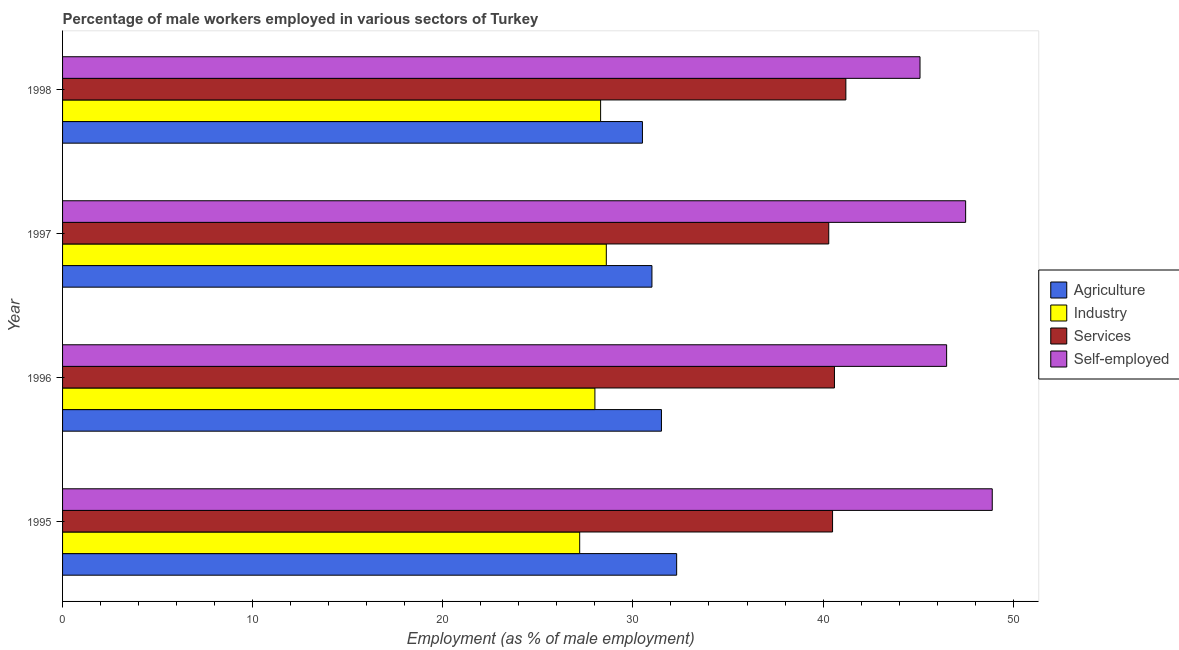How many different coloured bars are there?
Make the answer very short. 4. Are the number of bars per tick equal to the number of legend labels?
Offer a very short reply. Yes. How many bars are there on the 1st tick from the top?
Offer a very short reply. 4. How many bars are there on the 4th tick from the bottom?
Offer a terse response. 4. In how many cases, is the number of bars for a given year not equal to the number of legend labels?
Provide a short and direct response. 0. What is the percentage of male workers in agriculture in 1996?
Give a very brief answer. 31.5. Across all years, what is the maximum percentage of male workers in services?
Make the answer very short. 41.2. Across all years, what is the minimum percentage of male workers in agriculture?
Keep it short and to the point. 30.5. In which year was the percentage of male workers in industry minimum?
Give a very brief answer. 1995. What is the total percentage of male workers in agriculture in the graph?
Your response must be concise. 125.3. What is the difference between the percentage of self employed male workers in 1995 and that in 1996?
Ensure brevity in your answer.  2.4. What is the difference between the percentage of self employed male workers in 1997 and the percentage of male workers in agriculture in 1996?
Keep it short and to the point. 16. What is the average percentage of male workers in agriculture per year?
Offer a terse response. 31.32. In the year 1995, what is the difference between the percentage of male workers in services and percentage of male workers in agriculture?
Ensure brevity in your answer.  8.2. In how many years, is the percentage of male workers in services greater than 20 %?
Your response must be concise. 4. What is the ratio of the percentage of male workers in industry in 1995 to that in 1996?
Keep it short and to the point. 0.97. Is the difference between the percentage of male workers in services in 1996 and 1998 greater than the difference between the percentage of male workers in industry in 1996 and 1998?
Ensure brevity in your answer.  No. What is the difference between the highest and the lowest percentage of male workers in industry?
Your answer should be compact. 1.4. In how many years, is the percentage of self employed male workers greater than the average percentage of self employed male workers taken over all years?
Make the answer very short. 2. Is the sum of the percentage of male workers in agriculture in 1997 and 1998 greater than the maximum percentage of male workers in industry across all years?
Keep it short and to the point. Yes. Is it the case that in every year, the sum of the percentage of male workers in services and percentage of self employed male workers is greater than the sum of percentage of male workers in agriculture and percentage of male workers in industry?
Ensure brevity in your answer.  Yes. What does the 1st bar from the top in 1996 represents?
Provide a succinct answer. Self-employed. What does the 3rd bar from the bottom in 1998 represents?
Your answer should be compact. Services. How many bars are there?
Provide a succinct answer. 16. Are all the bars in the graph horizontal?
Ensure brevity in your answer.  Yes. What is the difference between two consecutive major ticks on the X-axis?
Offer a terse response. 10. Does the graph contain any zero values?
Make the answer very short. No. Does the graph contain grids?
Provide a succinct answer. No. Where does the legend appear in the graph?
Ensure brevity in your answer.  Center right. How are the legend labels stacked?
Provide a succinct answer. Vertical. What is the title of the graph?
Provide a succinct answer. Percentage of male workers employed in various sectors of Turkey. Does "Primary education" appear as one of the legend labels in the graph?
Ensure brevity in your answer.  No. What is the label or title of the X-axis?
Your answer should be compact. Employment (as % of male employment). What is the label or title of the Y-axis?
Your response must be concise. Year. What is the Employment (as % of male employment) of Agriculture in 1995?
Provide a short and direct response. 32.3. What is the Employment (as % of male employment) of Industry in 1995?
Give a very brief answer. 27.2. What is the Employment (as % of male employment) in Services in 1995?
Your response must be concise. 40.5. What is the Employment (as % of male employment) in Self-employed in 1995?
Your answer should be compact. 48.9. What is the Employment (as % of male employment) of Agriculture in 1996?
Your answer should be compact. 31.5. What is the Employment (as % of male employment) of Services in 1996?
Offer a terse response. 40.6. What is the Employment (as % of male employment) of Self-employed in 1996?
Make the answer very short. 46.5. What is the Employment (as % of male employment) in Agriculture in 1997?
Provide a succinct answer. 31. What is the Employment (as % of male employment) of Industry in 1997?
Your response must be concise. 28.6. What is the Employment (as % of male employment) in Services in 1997?
Make the answer very short. 40.3. What is the Employment (as % of male employment) in Self-employed in 1997?
Ensure brevity in your answer.  47.5. What is the Employment (as % of male employment) in Agriculture in 1998?
Provide a succinct answer. 30.5. What is the Employment (as % of male employment) in Industry in 1998?
Give a very brief answer. 28.3. What is the Employment (as % of male employment) of Services in 1998?
Provide a short and direct response. 41.2. What is the Employment (as % of male employment) in Self-employed in 1998?
Provide a short and direct response. 45.1. Across all years, what is the maximum Employment (as % of male employment) of Agriculture?
Ensure brevity in your answer.  32.3. Across all years, what is the maximum Employment (as % of male employment) of Industry?
Provide a short and direct response. 28.6. Across all years, what is the maximum Employment (as % of male employment) of Services?
Ensure brevity in your answer.  41.2. Across all years, what is the maximum Employment (as % of male employment) in Self-employed?
Give a very brief answer. 48.9. Across all years, what is the minimum Employment (as % of male employment) in Agriculture?
Keep it short and to the point. 30.5. Across all years, what is the minimum Employment (as % of male employment) of Industry?
Keep it short and to the point. 27.2. Across all years, what is the minimum Employment (as % of male employment) in Services?
Provide a short and direct response. 40.3. Across all years, what is the minimum Employment (as % of male employment) of Self-employed?
Ensure brevity in your answer.  45.1. What is the total Employment (as % of male employment) of Agriculture in the graph?
Provide a short and direct response. 125.3. What is the total Employment (as % of male employment) in Industry in the graph?
Keep it short and to the point. 112.1. What is the total Employment (as % of male employment) of Services in the graph?
Make the answer very short. 162.6. What is the total Employment (as % of male employment) in Self-employed in the graph?
Make the answer very short. 188. What is the difference between the Employment (as % of male employment) in Agriculture in 1995 and that in 1996?
Your response must be concise. 0.8. What is the difference between the Employment (as % of male employment) in Industry in 1995 and that in 1996?
Ensure brevity in your answer.  -0.8. What is the difference between the Employment (as % of male employment) of Services in 1995 and that in 1996?
Your answer should be very brief. -0.1. What is the difference between the Employment (as % of male employment) in Self-employed in 1995 and that in 1996?
Your answer should be compact. 2.4. What is the difference between the Employment (as % of male employment) in Agriculture in 1995 and that in 1997?
Your answer should be very brief. 1.3. What is the difference between the Employment (as % of male employment) in Industry in 1995 and that in 1997?
Make the answer very short. -1.4. What is the difference between the Employment (as % of male employment) of Self-employed in 1995 and that in 1997?
Your response must be concise. 1.4. What is the difference between the Employment (as % of male employment) of Industry in 1995 and that in 1998?
Make the answer very short. -1.1. What is the difference between the Employment (as % of male employment) in Services in 1995 and that in 1998?
Ensure brevity in your answer.  -0.7. What is the difference between the Employment (as % of male employment) in Self-employed in 1995 and that in 1998?
Provide a succinct answer. 3.8. What is the difference between the Employment (as % of male employment) of Agriculture in 1996 and that in 1997?
Give a very brief answer. 0.5. What is the difference between the Employment (as % of male employment) of Industry in 1996 and that in 1997?
Offer a very short reply. -0.6. What is the difference between the Employment (as % of male employment) in Services in 1996 and that in 1997?
Your response must be concise. 0.3. What is the difference between the Employment (as % of male employment) of Self-employed in 1996 and that in 1997?
Offer a terse response. -1. What is the difference between the Employment (as % of male employment) of Industry in 1996 and that in 1998?
Give a very brief answer. -0.3. What is the difference between the Employment (as % of male employment) of Self-employed in 1996 and that in 1998?
Offer a terse response. 1.4. What is the difference between the Employment (as % of male employment) in Industry in 1997 and that in 1998?
Make the answer very short. 0.3. What is the difference between the Employment (as % of male employment) in Self-employed in 1997 and that in 1998?
Offer a terse response. 2.4. What is the difference between the Employment (as % of male employment) of Agriculture in 1995 and the Employment (as % of male employment) of Industry in 1996?
Offer a very short reply. 4.3. What is the difference between the Employment (as % of male employment) in Agriculture in 1995 and the Employment (as % of male employment) in Self-employed in 1996?
Keep it short and to the point. -14.2. What is the difference between the Employment (as % of male employment) in Industry in 1995 and the Employment (as % of male employment) in Services in 1996?
Give a very brief answer. -13.4. What is the difference between the Employment (as % of male employment) of Industry in 1995 and the Employment (as % of male employment) of Self-employed in 1996?
Provide a short and direct response. -19.3. What is the difference between the Employment (as % of male employment) in Services in 1995 and the Employment (as % of male employment) in Self-employed in 1996?
Ensure brevity in your answer.  -6. What is the difference between the Employment (as % of male employment) in Agriculture in 1995 and the Employment (as % of male employment) in Industry in 1997?
Make the answer very short. 3.7. What is the difference between the Employment (as % of male employment) in Agriculture in 1995 and the Employment (as % of male employment) in Self-employed in 1997?
Keep it short and to the point. -15.2. What is the difference between the Employment (as % of male employment) of Industry in 1995 and the Employment (as % of male employment) of Self-employed in 1997?
Offer a very short reply. -20.3. What is the difference between the Employment (as % of male employment) of Agriculture in 1995 and the Employment (as % of male employment) of Industry in 1998?
Your response must be concise. 4. What is the difference between the Employment (as % of male employment) of Agriculture in 1995 and the Employment (as % of male employment) of Services in 1998?
Make the answer very short. -8.9. What is the difference between the Employment (as % of male employment) of Agriculture in 1995 and the Employment (as % of male employment) of Self-employed in 1998?
Provide a succinct answer. -12.8. What is the difference between the Employment (as % of male employment) of Industry in 1995 and the Employment (as % of male employment) of Services in 1998?
Provide a short and direct response. -14. What is the difference between the Employment (as % of male employment) of Industry in 1995 and the Employment (as % of male employment) of Self-employed in 1998?
Provide a succinct answer. -17.9. What is the difference between the Employment (as % of male employment) of Services in 1995 and the Employment (as % of male employment) of Self-employed in 1998?
Your response must be concise. -4.6. What is the difference between the Employment (as % of male employment) in Agriculture in 1996 and the Employment (as % of male employment) in Industry in 1997?
Ensure brevity in your answer.  2.9. What is the difference between the Employment (as % of male employment) in Agriculture in 1996 and the Employment (as % of male employment) in Services in 1997?
Provide a short and direct response. -8.8. What is the difference between the Employment (as % of male employment) in Agriculture in 1996 and the Employment (as % of male employment) in Self-employed in 1997?
Your response must be concise. -16. What is the difference between the Employment (as % of male employment) of Industry in 1996 and the Employment (as % of male employment) of Services in 1997?
Provide a succinct answer. -12.3. What is the difference between the Employment (as % of male employment) in Industry in 1996 and the Employment (as % of male employment) in Self-employed in 1997?
Your answer should be compact. -19.5. What is the difference between the Employment (as % of male employment) of Services in 1996 and the Employment (as % of male employment) of Self-employed in 1997?
Give a very brief answer. -6.9. What is the difference between the Employment (as % of male employment) of Agriculture in 1996 and the Employment (as % of male employment) of Industry in 1998?
Offer a terse response. 3.2. What is the difference between the Employment (as % of male employment) in Industry in 1996 and the Employment (as % of male employment) in Self-employed in 1998?
Your answer should be compact. -17.1. What is the difference between the Employment (as % of male employment) of Agriculture in 1997 and the Employment (as % of male employment) of Industry in 1998?
Your response must be concise. 2.7. What is the difference between the Employment (as % of male employment) in Agriculture in 1997 and the Employment (as % of male employment) in Services in 1998?
Provide a succinct answer. -10.2. What is the difference between the Employment (as % of male employment) of Agriculture in 1997 and the Employment (as % of male employment) of Self-employed in 1998?
Provide a succinct answer. -14.1. What is the difference between the Employment (as % of male employment) of Industry in 1997 and the Employment (as % of male employment) of Services in 1998?
Give a very brief answer. -12.6. What is the difference between the Employment (as % of male employment) of Industry in 1997 and the Employment (as % of male employment) of Self-employed in 1998?
Keep it short and to the point. -16.5. What is the difference between the Employment (as % of male employment) in Services in 1997 and the Employment (as % of male employment) in Self-employed in 1998?
Give a very brief answer. -4.8. What is the average Employment (as % of male employment) of Agriculture per year?
Provide a succinct answer. 31.32. What is the average Employment (as % of male employment) of Industry per year?
Your answer should be very brief. 28.02. What is the average Employment (as % of male employment) of Services per year?
Make the answer very short. 40.65. In the year 1995, what is the difference between the Employment (as % of male employment) in Agriculture and Employment (as % of male employment) in Services?
Your answer should be compact. -8.2. In the year 1995, what is the difference between the Employment (as % of male employment) in Agriculture and Employment (as % of male employment) in Self-employed?
Offer a terse response. -16.6. In the year 1995, what is the difference between the Employment (as % of male employment) in Industry and Employment (as % of male employment) in Services?
Provide a succinct answer. -13.3. In the year 1995, what is the difference between the Employment (as % of male employment) in Industry and Employment (as % of male employment) in Self-employed?
Provide a short and direct response. -21.7. In the year 1995, what is the difference between the Employment (as % of male employment) in Services and Employment (as % of male employment) in Self-employed?
Offer a very short reply. -8.4. In the year 1996, what is the difference between the Employment (as % of male employment) of Agriculture and Employment (as % of male employment) of Services?
Provide a succinct answer. -9.1. In the year 1996, what is the difference between the Employment (as % of male employment) of Industry and Employment (as % of male employment) of Self-employed?
Provide a succinct answer. -18.5. In the year 1996, what is the difference between the Employment (as % of male employment) of Services and Employment (as % of male employment) of Self-employed?
Ensure brevity in your answer.  -5.9. In the year 1997, what is the difference between the Employment (as % of male employment) of Agriculture and Employment (as % of male employment) of Industry?
Ensure brevity in your answer.  2.4. In the year 1997, what is the difference between the Employment (as % of male employment) of Agriculture and Employment (as % of male employment) of Self-employed?
Offer a terse response. -16.5. In the year 1997, what is the difference between the Employment (as % of male employment) of Industry and Employment (as % of male employment) of Self-employed?
Provide a succinct answer. -18.9. In the year 1997, what is the difference between the Employment (as % of male employment) of Services and Employment (as % of male employment) of Self-employed?
Your answer should be compact. -7.2. In the year 1998, what is the difference between the Employment (as % of male employment) in Agriculture and Employment (as % of male employment) in Self-employed?
Offer a terse response. -14.6. In the year 1998, what is the difference between the Employment (as % of male employment) of Industry and Employment (as % of male employment) of Services?
Your answer should be compact. -12.9. In the year 1998, what is the difference between the Employment (as % of male employment) in Industry and Employment (as % of male employment) in Self-employed?
Keep it short and to the point. -16.8. In the year 1998, what is the difference between the Employment (as % of male employment) of Services and Employment (as % of male employment) of Self-employed?
Make the answer very short. -3.9. What is the ratio of the Employment (as % of male employment) in Agriculture in 1995 to that in 1996?
Offer a terse response. 1.03. What is the ratio of the Employment (as % of male employment) in Industry in 1995 to that in 1996?
Ensure brevity in your answer.  0.97. What is the ratio of the Employment (as % of male employment) of Services in 1995 to that in 1996?
Your answer should be compact. 1. What is the ratio of the Employment (as % of male employment) in Self-employed in 1995 to that in 1996?
Offer a very short reply. 1.05. What is the ratio of the Employment (as % of male employment) of Agriculture in 1995 to that in 1997?
Offer a very short reply. 1.04. What is the ratio of the Employment (as % of male employment) in Industry in 1995 to that in 1997?
Give a very brief answer. 0.95. What is the ratio of the Employment (as % of male employment) in Self-employed in 1995 to that in 1997?
Offer a terse response. 1.03. What is the ratio of the Employment (as % of male employment) of Agriculture in 1995 to that in 1998?
Give a very brief answer. 1.06. What is the ratio of the Employment (as % of male employment) of Industry in 1995 to that in 1998?
Ensure brevity in your answer.  0.96. What is the ratio of the Employment (as % of male employment) in Self-employed in 1995 to that in 1998?
Your response must be concise. 1.08. What is the ratio of the Employment (as % of male employment) of Agriculture in 1996 to that in 1997?
Keep it short and to the point. 1.02. What is the ratio of the Employment (as % of male employment) in Industry in 1996 to that in 1997?
Ensure brevity in your answer.  0.98. What is the ratio of the Employment (as % of male employment) of Services in 1996 to that in 1997?
Your response must be concise. 1.01. What is the ratio of the Employment (as % of male employment) in Self-employed in 1996 to that in 1997?
Keep it short and to the point. 0.98. What is the ratio of the Employment (as % of male employment) in Agriculture in 1996 to that in 1998?
Your response must be concise. 1.03. What is the ratio of the Employment (as % of male employment) in Industry in 1996 to that in 1998?
Keep it short and to the point. 0.99. What is the ratio of the Employment (as % of male employment) of Services in 1996 to that in 1998?
Give a very brief answer. 0.99. What is the ratio of the Employment (as % of male employment) in Self-employed in 1996 to that in 1998?
Provide a short and direct response. 1.03. What is the ratio of the Employment (as % of male employment) of Agriculture in 1997 to that in 1998?
Your answer should be compact. 1.02. What is the ratio of the Employment (as % of male employment) in Industry in 1997 to that in 1998?
Your response must be concise. 1.01. What is the ratio of the Employment (as % of male employment) in Services in 1997 to that in 1998?
Your answer should be compact. 0.98. What is the ratio of the Employment (as % of male employment) of Self-employed in 1997 to that in 1998?
Give a very brief answer. 1.05. What is the difference between the highest and the second highest Employment (as % of male employment) in Agriculture?
Keep it short and to the point. 0.8. What is the difference between the highest and the second highest Employment (as % of male employment) in Industry?
Offer a very short reply. 0.3. What is the difference between the highest and the lowest Employment (as % of male employment) of Industry?
Your answer should be very brief. 1.4. What is the difference between the highest and the lowest Employment (as % of male employment) of Self-employed?
Your answer should be very brief. 3.8. 